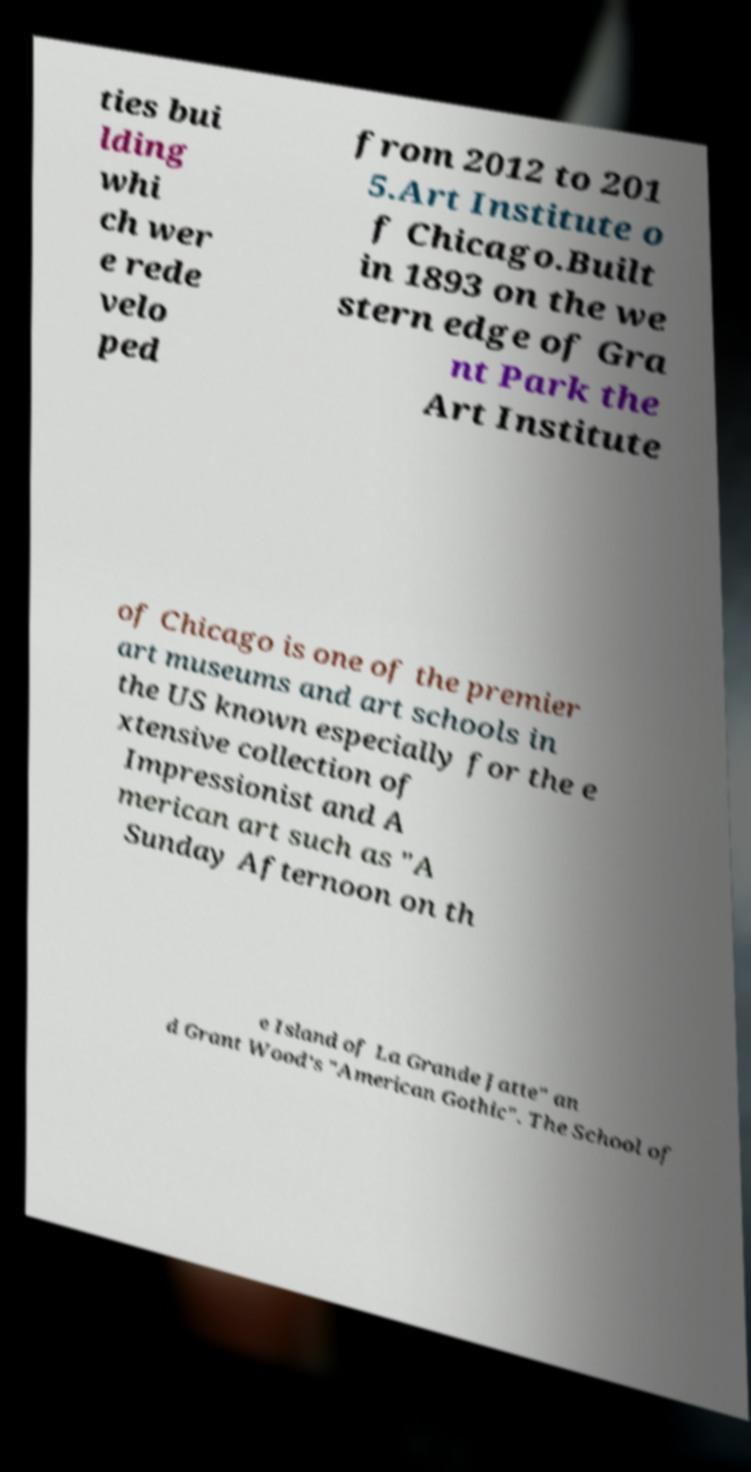I need the written content from this picture converted into text. Can you do that? ties bui lding whi ch wer e rede velo ped from 2012 to 201 5.Art Institute o f Chicago.Built in 1893 on the we stern edge of Gra nt Park the Art Institute of Chicago is one of the premier art museums and art schools in the US known especially for the e xtensive collection of Impressionist and A merican art such as "A Sunday Afternoon on th e Island of La Grande Jatte" an d Grant Wood's "American Gothic". The School of 